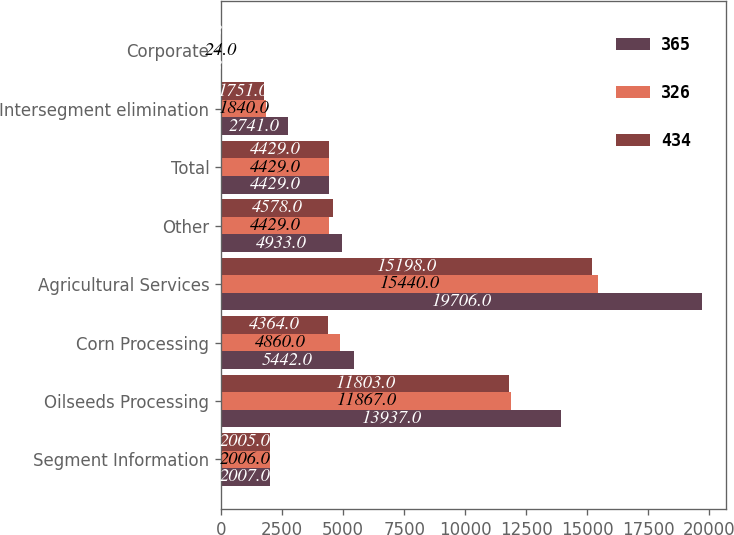Convert chart. <chart><loc_0><loc_0><loc_500><loc_500><stacked_bar_chart><ecel><fcel>Segment Information<fcel>Oilseeds Processing<fcel>Corn Processing<fcel>Agricultural Services<fcel>Other<fcel>Total<fcel>Intersegment elimination<fcel>Corporate<nl><fcel>365<fcel>2007<fcel>13937<fcel>5442<fcel>19706<fcel>4933<fcel>4429<fcel>2741<fcel>23<nl><fcel>326<fcel>2006<fcel>11867<fcel>4860<fcel>15440<fcel>4429<fcel>4429<fcel>1840<fcel>24<nl><fcel>434<fcel>2005<fcel>11803<fcel>4364<fcel>15198<fcel>4578<fcel>4429<fcel>1751<fcel>23<nl></chart> 